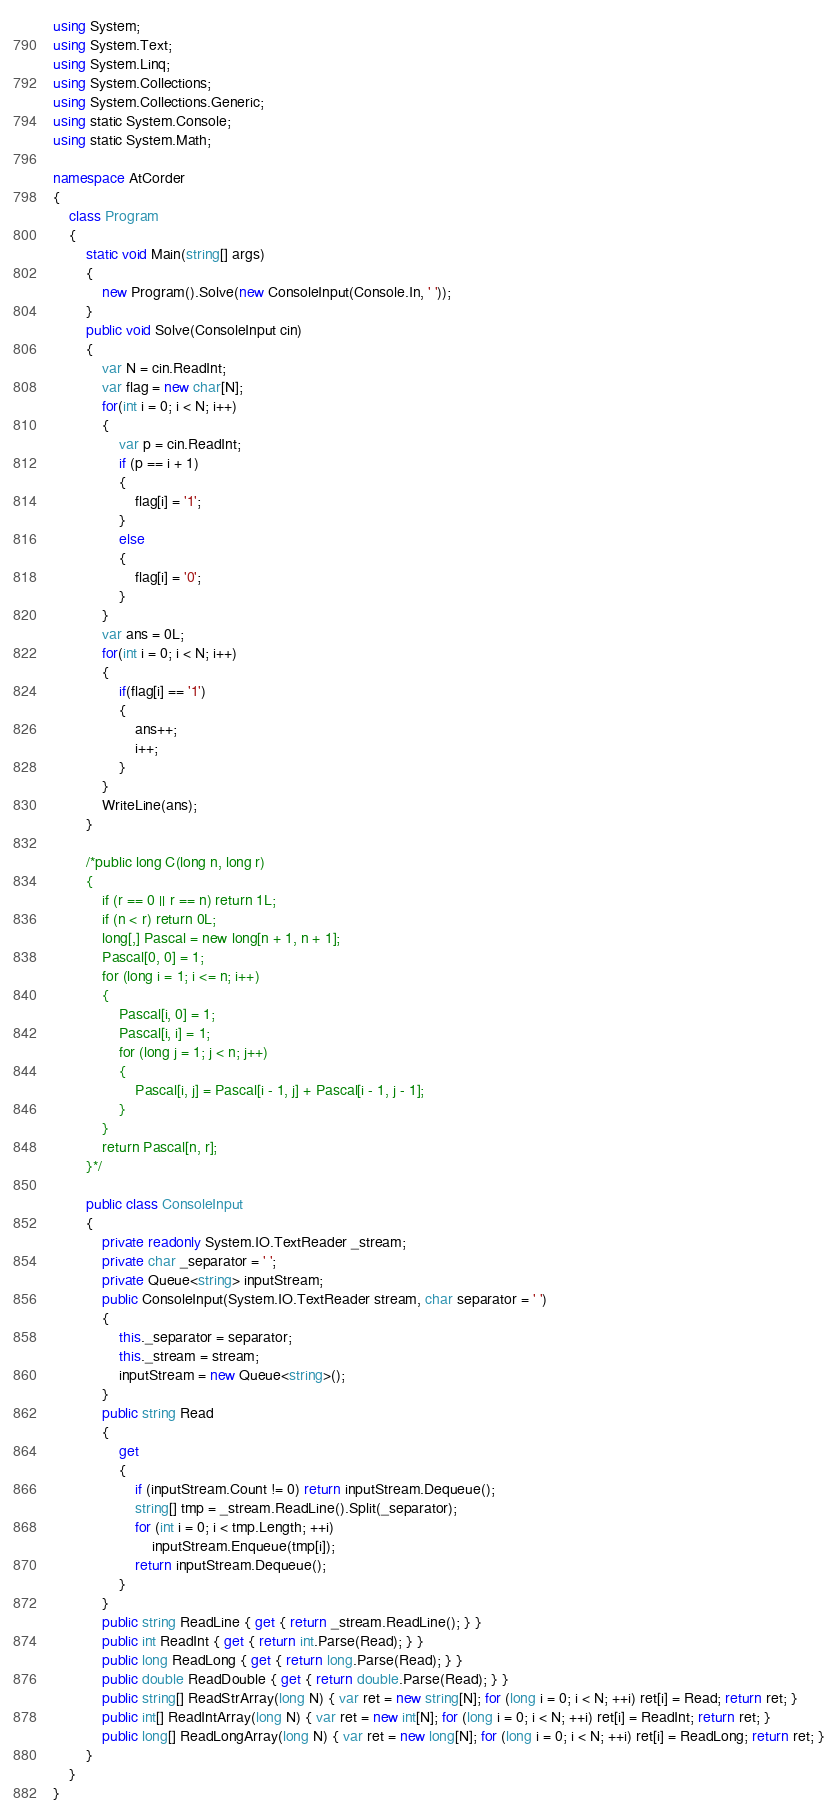<code> <loc_0><loc_0><loc_500><loc_500><_C#_>using System;
using System.Text;
using System.Linq;
using System.Collections;
using System.Collections.Generic;
using static System.Console;
using static System.Math;

namespace AtCorder
{
    class Program
    {
        static void Main(string[] args)
        {
            new Program().Solve(new ConsoleInput(Console.In, ' '));
        }
        public void Solve(ConsoleInput cin)
        {
            var N = cin.ReadInt;
            var flag = new char[N];
            for(int i = 0; i < N; i++)
            {
                var p = cin.ReadInt;
                if (p == i + 1)
                {
                    flag[i] = '1';
                }
                else
                {
                    flag[i] = '0';
                }
            }
            var ans = 0L;
            for(int i = 0; i < N; i++)
            {
                if(flag[i] == '1')
                {
                    ans++;
                    i++;
                }
            }
            WriteLine(ans);
        }

        /*public long C(long n, long r)
        {
            if (r == 0 || r == n) return 1L;
            if (n < r) return 0L;
            long[,] Pascal = new long[n + 1, n + 1];
            Pascal[0, 0] = 1;
            for (long i = 1; i <= n; i++)
            {
                Pascal[i, 0] = 1;
                Pascal[i, i] = 1;
                for (long j = 1; j < n; j++)
                {
                    Pascal[i, j] = Pascal[i - 1, j] + Pascal[i - 1, j - 1];
                }
            }
            return Pascal[n, r];
        }*/

        public class ConsoleInput
        {
            private readonly System.IO.TextReader _stream;
            private char _separator = ' ';
            private Queue<string> inputStream;
            public ConsoleInput(System.IO.TextReader stream, char separator = ' ')
            {
                this._separator = separator;
                this._stream = stream;
                inputStream = new Queue<string>();
            }
            public string Read
            {
                get
                {
                    if (inputStream.Count != 0) return inputStream.Dequeue();
                    string[] tmp = _stream.ReadLine().Split(_separator);
                    for (int i = 0; i < tmp.Length; ++i)
                        inputStream.Enqueue(tmp[i]);
                    return inputStream.Dequeue();
                }
            }
            public string ReadLine { get { return _stream.ReadLine(); } }
            public int ReadInt { get { return int.Parse(Read); } }
            public long ReadLong { get { return long.Parse(Read); } }
            public double ReadDouble { get { return double.Parse(Read); } }
            public string[] ReadStrArray(long N) { var ret = new string[N]; for (long i = 0; i < N; ++i) ret[i] = Read; return ret; }
            public int[] ReadIntArray(long N) { var ret = new int[N]; for (long i = 0; i < N; ++i) ret[i] = ReadInt; return ret; }
            public long[] ReadLongArray(long N) { var ret = new long[N]; for (long i = 0; i < N; ++i) ret[i] = ReadLong; return ret; }
        }
    }
}
</code> 